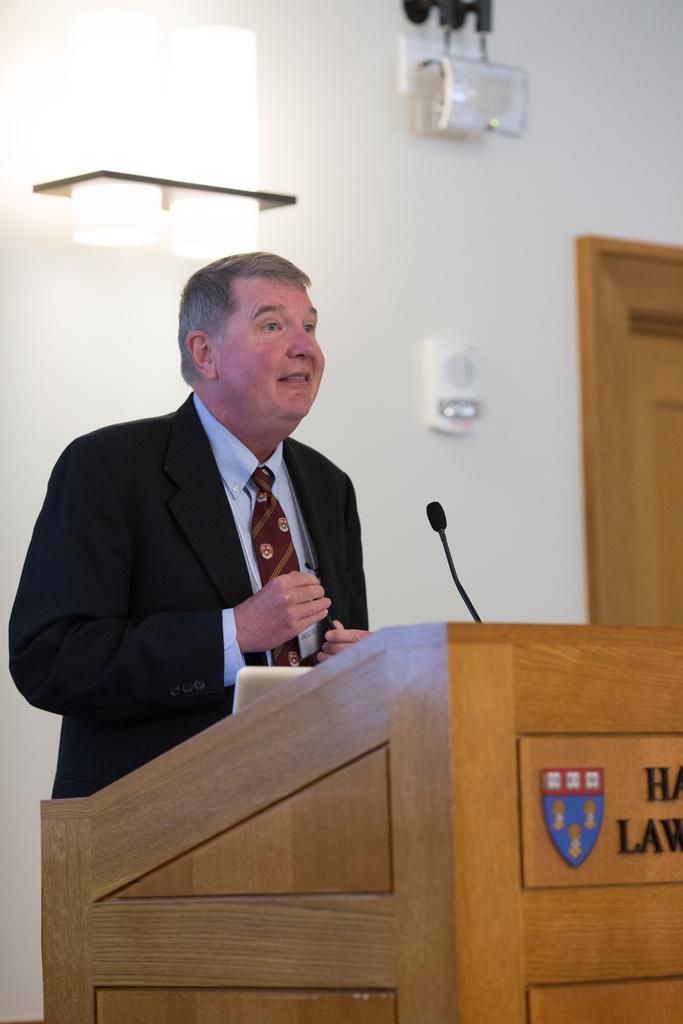In one or two sentences, can you explain what this image depicts? In the background we can see the wall, door, light and objects on the wall. In this picture we can see a man wearing a blazer, shirt and a tie. He is standing near to a podium and talking. We can see a mike and white color object and on the front portion of the podium we can see there is something written and a logo. 